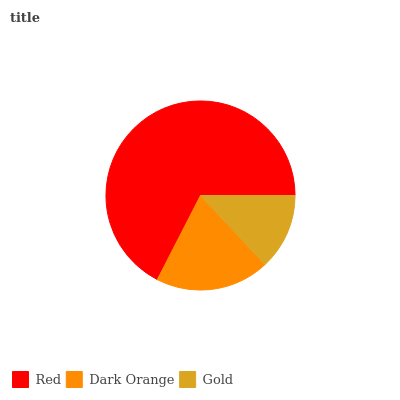Is Gold the minimum?
Answer yes or no. Yes. Is Red the maximum?
Answer yes or no. Yes. Is Dark Orange the minimum?
Answer yes or no. No. Is Dark Orange the maximum?
Answer yes or no. No. Is Red greater than Dark Orange?
Answer yes or no. Yes. Is Dark Orange less than Red?
Answer yes or no. Yes. Is Dark Orange greater than Red?
Answer yes or no. No. Is Red less than Dark Orange?
Answer yes or no. No. Is Dark Orange the high median?
Answer yes or no. Yes. Is Dark Orange the low median?
Answer yes or no. Yes. Is Red the high median?
Answer yes or no. No. Is Gold the low median?
Answer yes or no. No. 